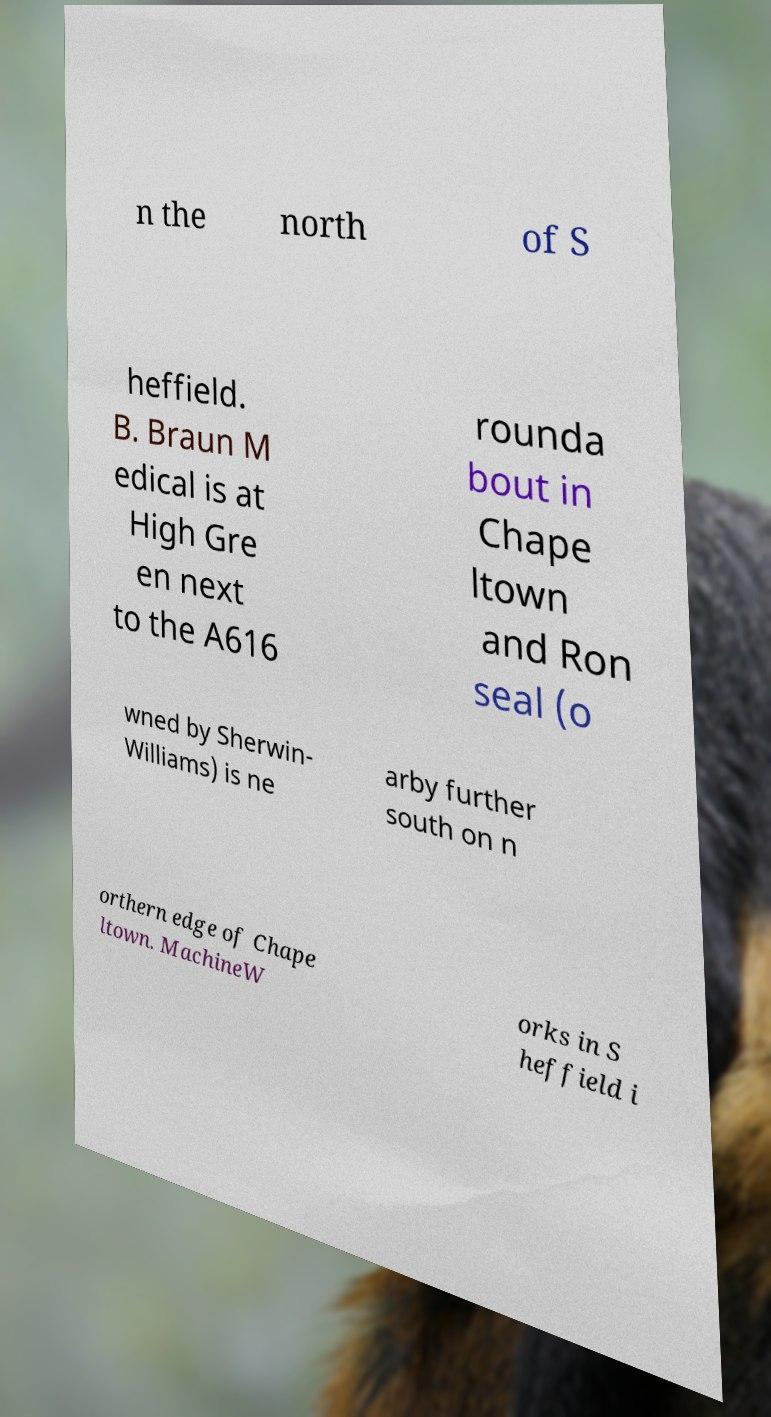Could you extract and type out the text from this image? n the north of S heffield. B. Braun M edical is at High Gre en next to the A616 rounda bout in Chape ltown and Ron seal (o wned by Sherwin- Williams) is ne arby further south on n orthern edge of Chape ltown. MachineW orks in S heffield i 